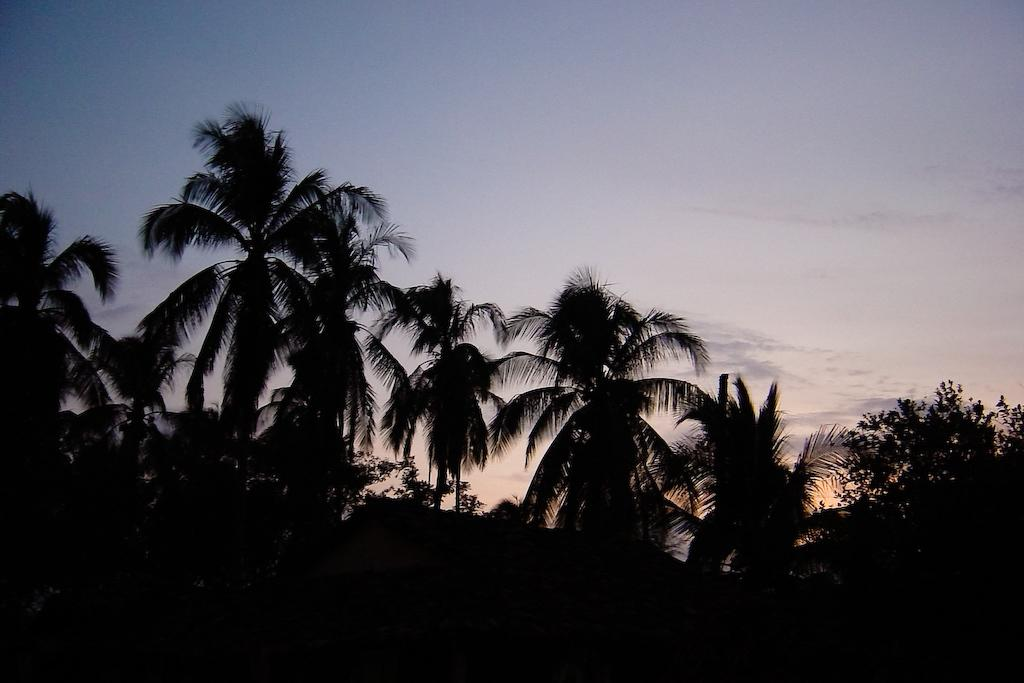What is the overall lighting condition of the image? The image is dark. What type of vegetation can be seen in the image? There are trees in the image. What can be seen in the background of the image? The sky is visible in the background of the image. What type of drink is the bear holding in the image? There is no bear or drink present in the image. 